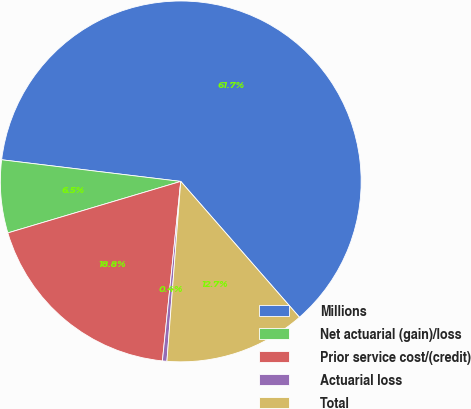<chart> <loc_0><loc_0><loc_500><loc_500><pie_chart><fcel>Millions<fcel>Net actuarial (gain)/loss<fcel>Prior service cost/(credit)<fcel>Actuarial loss<fcel>Total<nl><fcel>61.65%<fcel>6.52%<fcel>18.77%<fcel>0.4%<fcel>12.65%<nl></chart> 